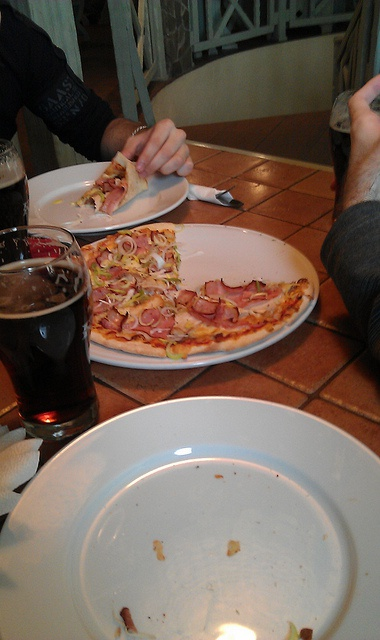Describe the objects in this image and their specific colors. I can see dining table in black, darkgray, maroon, and gray tones, pizza in black, brown, and tan tones, cup in black, maroon, and gray tones, people in black, brown, maroon, and gray tones, and people in black, gray, brown, and maroon tones in this image. 